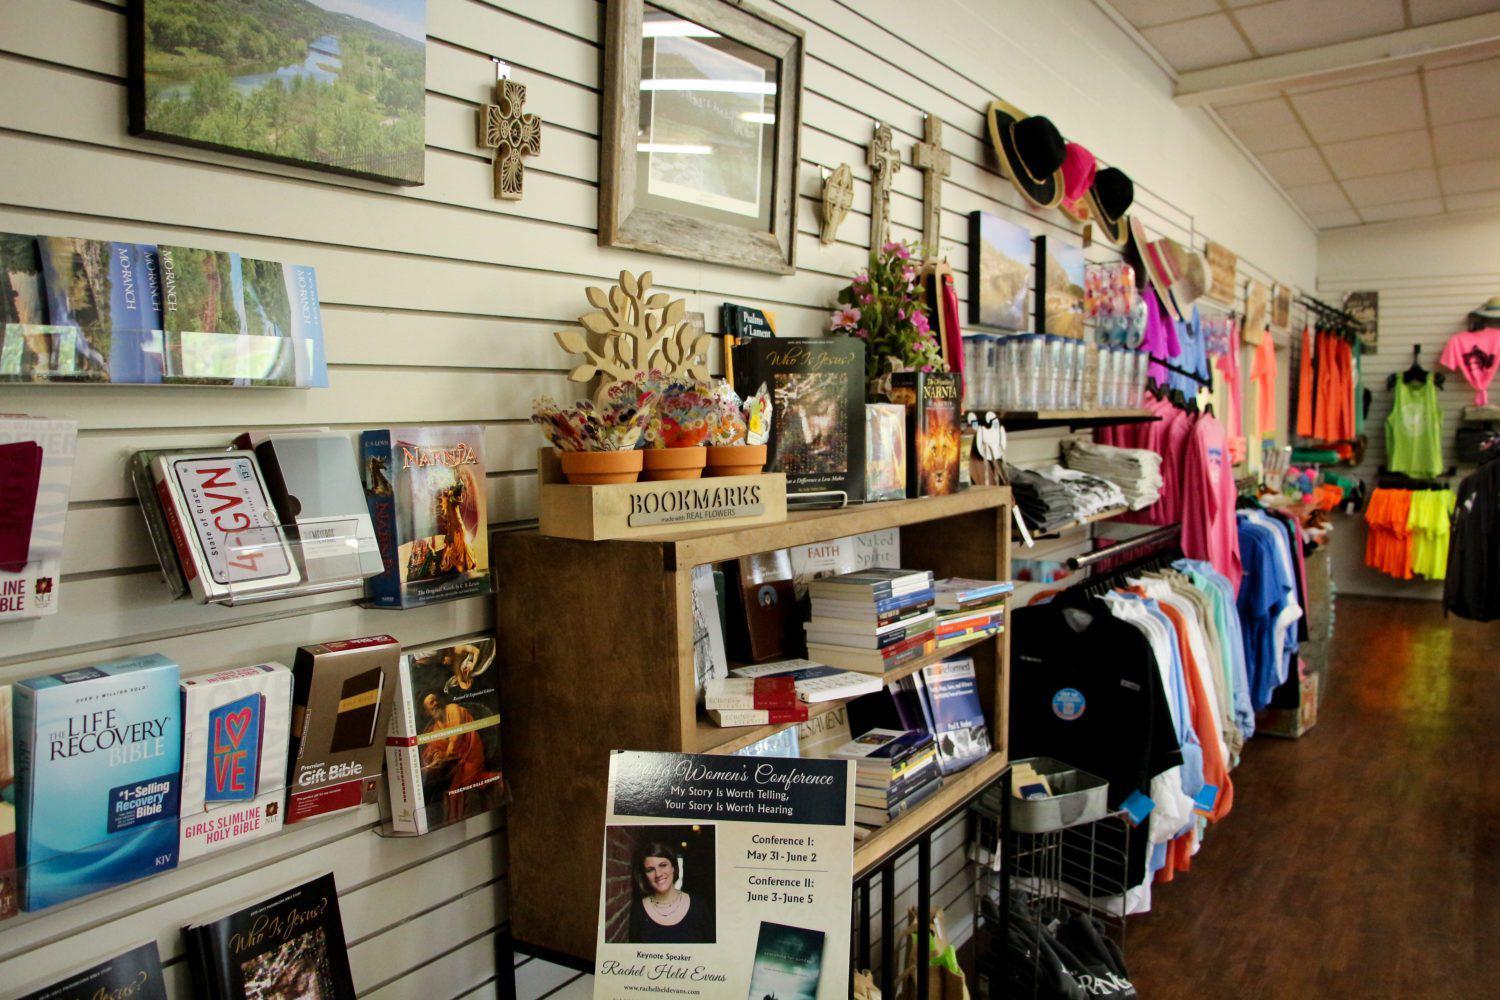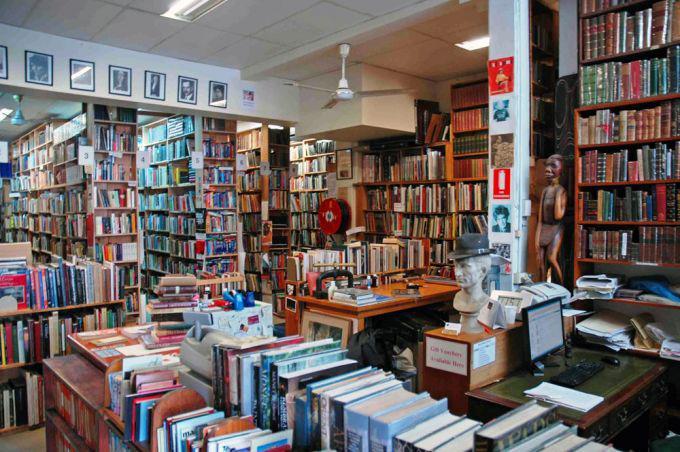The first image is the image on the left, the second image is the image on the right. Analyze the images presented: Is the assertion "There is 1 or more person(s) browsing the book selections." valid? Answer yes or no. No. The first image is the image on the left, the second image is the image on the right. Analyze the images presented: Is the assertion "There is a person in at least one of the photos." valid? Answer yes or no. No. 